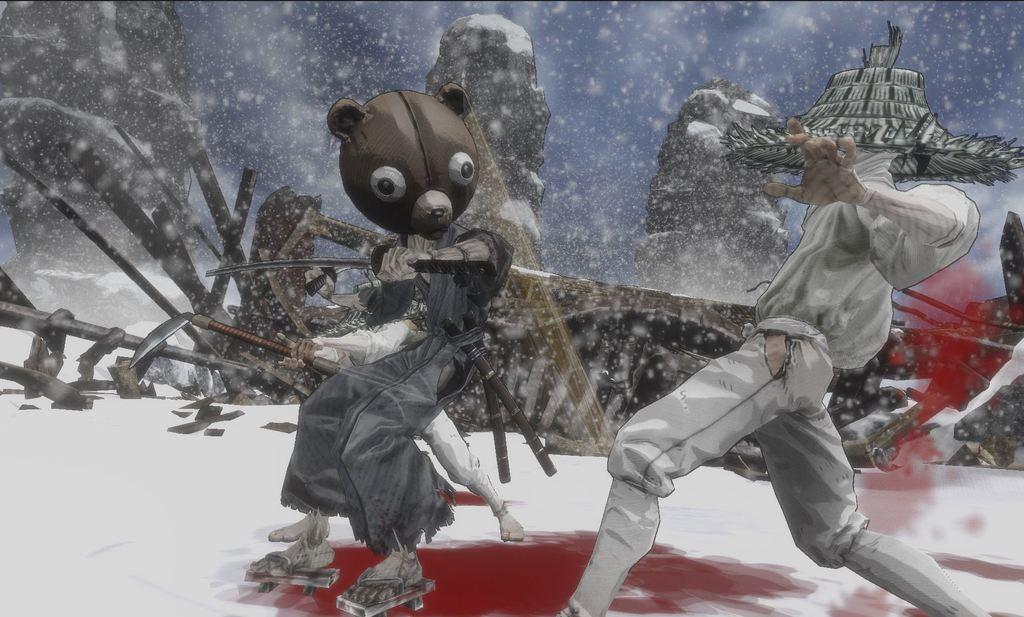What type of image is this? The image appears to be animated. What are the people in the image doing? The people are standing and holding weapons. What is the environment like in the image? The setting is in the snow. What can be seen in the background of the image? There are objects visible in the background. Can you hear the noise made by the hen in the image? There is no hen present in the image, so it is not possible to hear any noise made by a hen. 